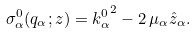<formula> <loc_0><loc_0><loc_500><loc_500>\sigma _ { \alpha } ^ { 0 } ( q _ { \alpha } ; z ) = { k _ { \alpha } ^ { 0 } } ^ { 2 } - 2 \, \mu _ { \alpha } { \hat { z } } _ { \alpha } .</formula> 